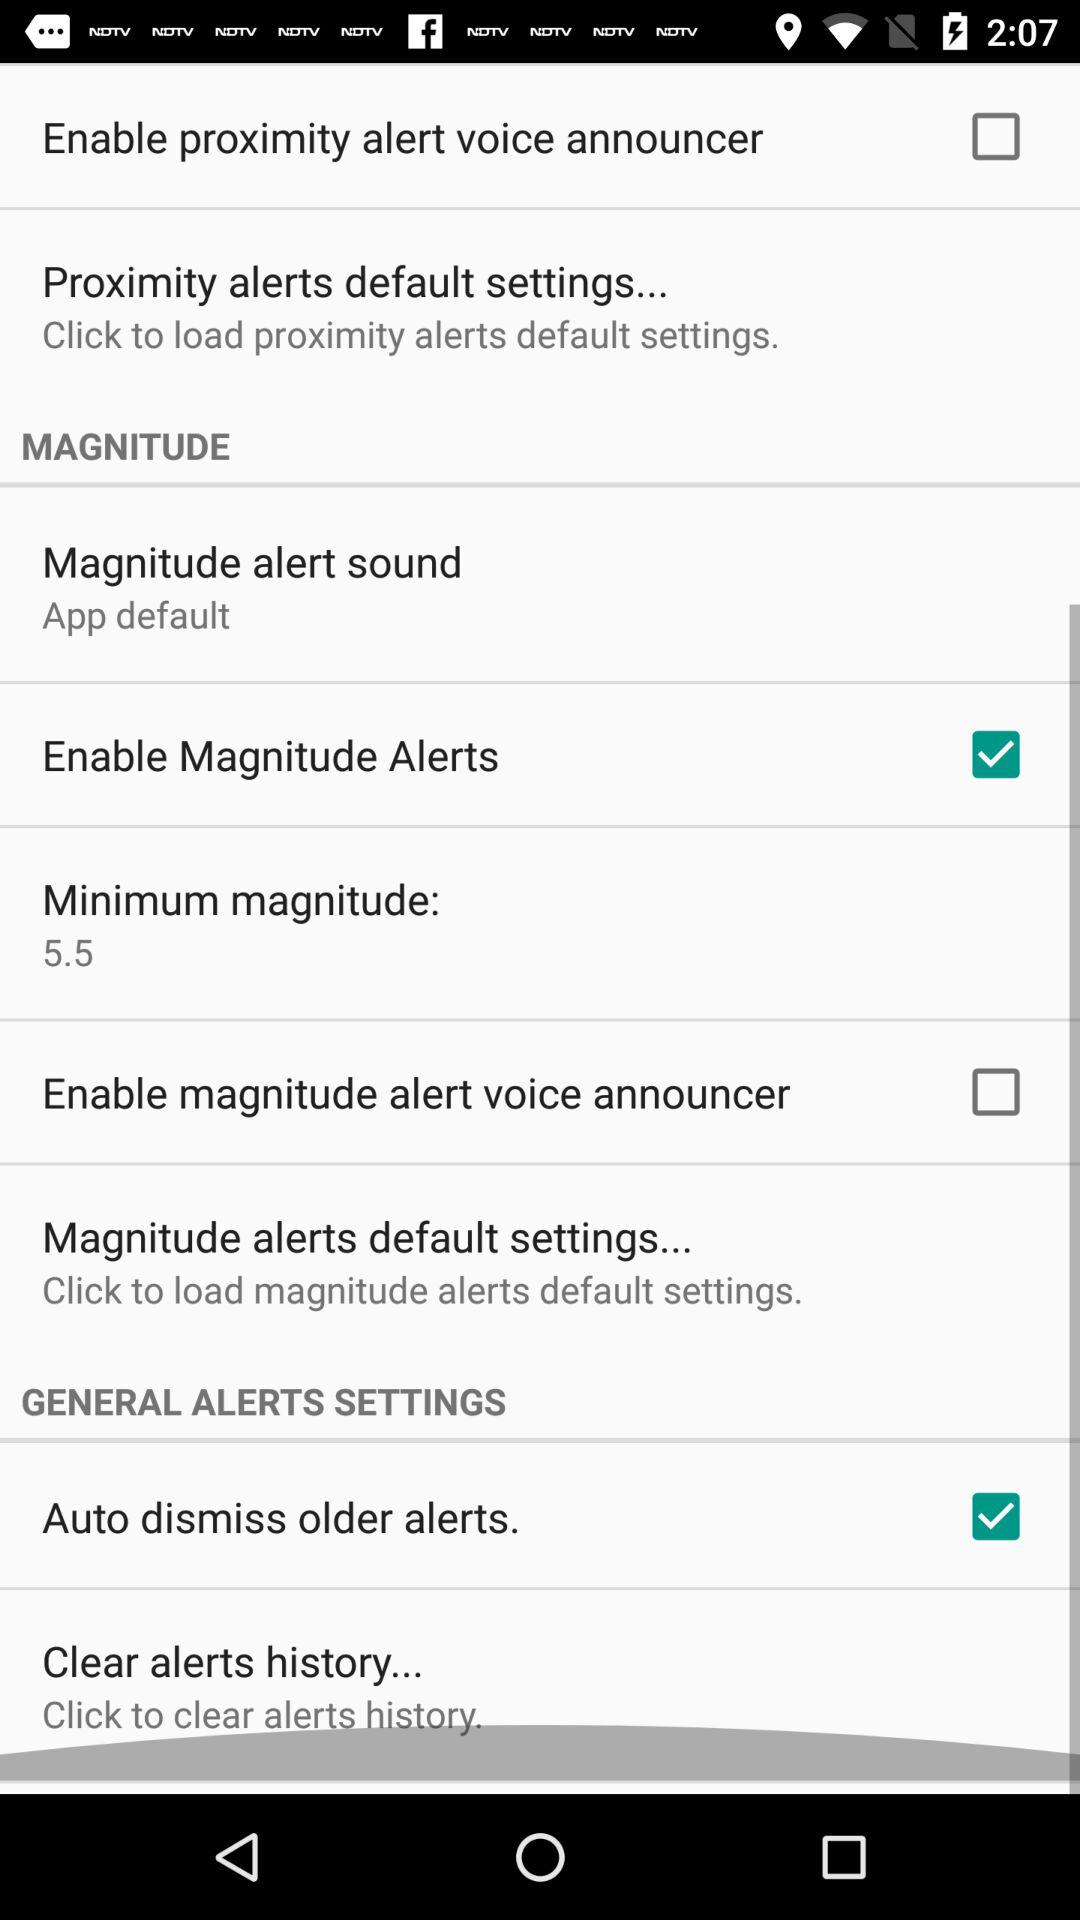What is the status of the "Enable Magnitude Alerts"? The status is on. 